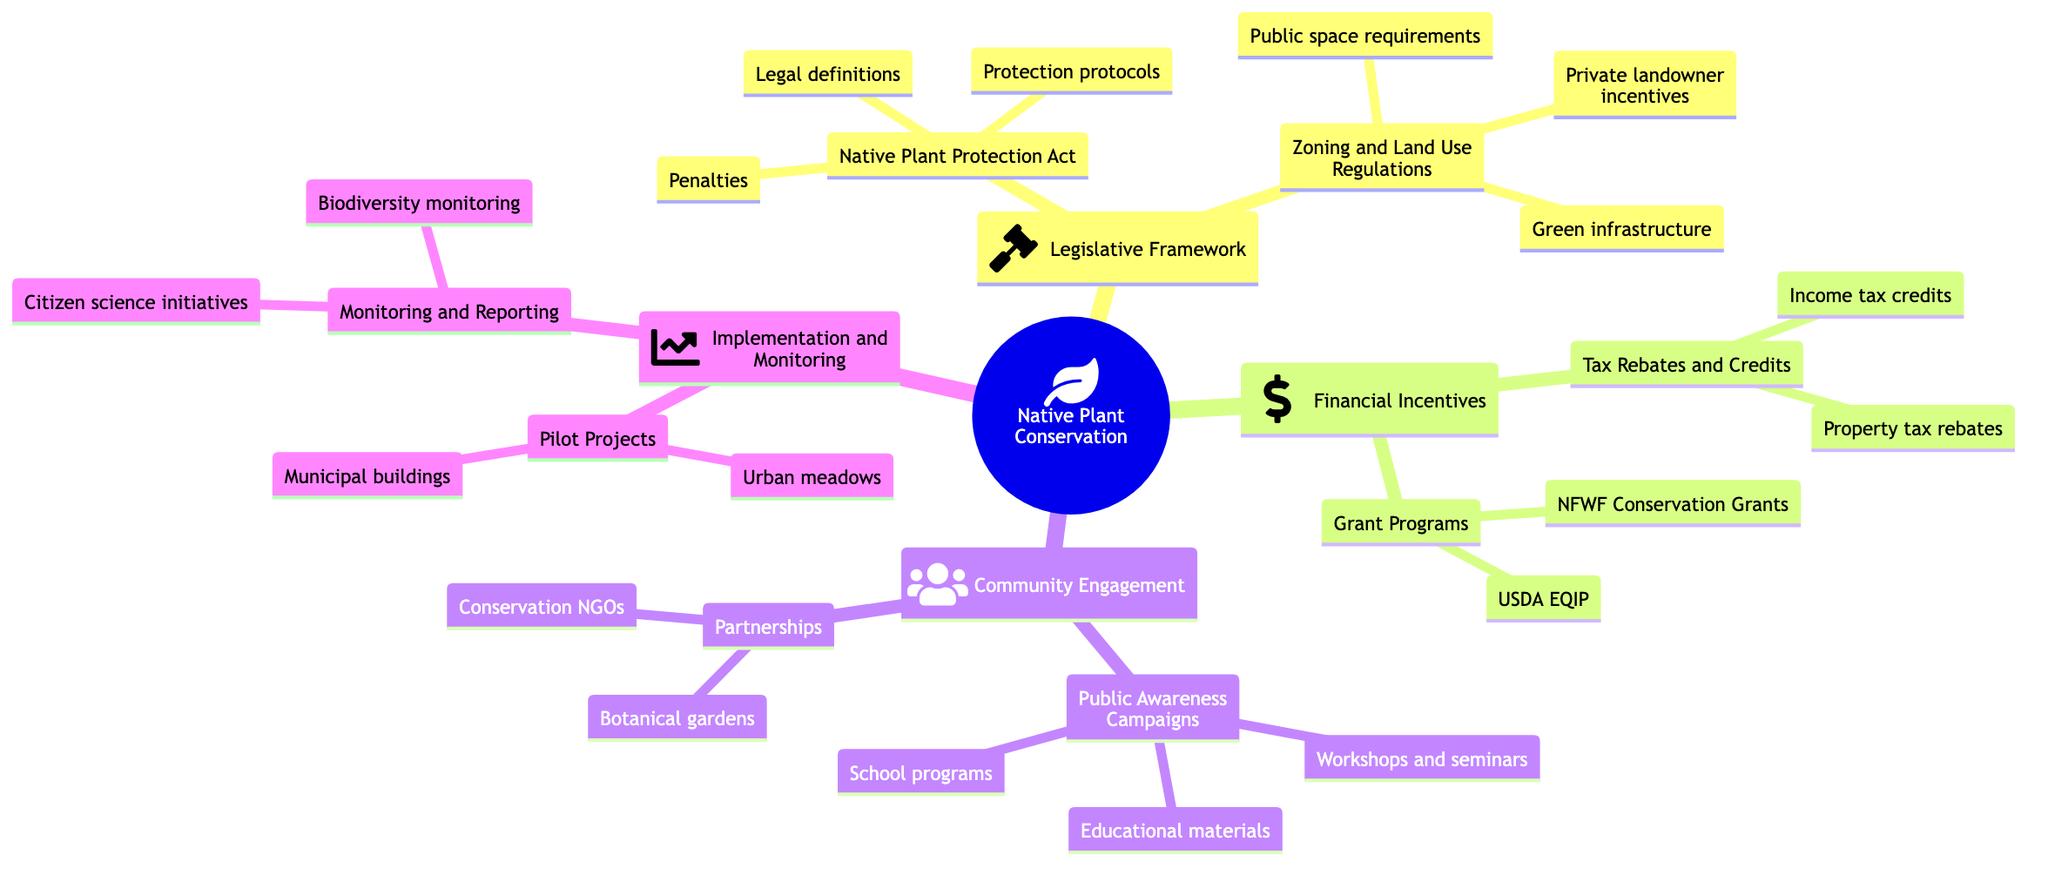What is one example of legislation protecting native plants? The diagram lists two examples under the "Native Plant Protection Act", which include the "California Native Plant Protection Act" and the "New York State Invasive Species Act".
Answer: California Native Plant Protection Act How many components are listed under "Tax Rebates and Credits"? The "Tax Rebates and Credits" section has two components: "Property tax rebates" and "Income tax credits". Thus, the count is based on these components.
Answer: 2 What is the purpose of "Public Awareness Campaigns"? The diagram states that the component aims to educate and involve the community, indicating its role in promoting understanding and engagement regarding native plant conservation.
Answer: Educate and involve Which section contains "Urban meadows in public parks"? The mention of "Urban meadows in public parks" identifies it as an example under "Pilot Projects", which is located within the "Implementation and Monitoring" section.
Answer: Pilot Projects What are two financial benefits mentioned for using native plants? The diagram highlights "Property tax rebates" and "Income tax credits" as benefits under "Tax Rebates and Credits". Therefore, they specifically apply to the financial incentives for native plant landscaping.
Answer: Property tax rebates, Income tax credits How many main categories are there in this mind map? The main branches include "Legislative Framework," "Financial Incentives," "Community Engagement," and "Implementation and Monitoring," totaling four primary categories depicted in the mind map.
Answer: 4 What is one example of a partnership mentioned in the diagram? Under "Partnerships with Local Organizations", the diagram lists "Collaborations with local botanical gardens" as an example, showcasing collaboration with an organization focused on plant conservation.
Answer: Collaborations with local botanical gardens What is the main goal of "Monitoring and Reporting"? The diagram notes that the purpose is ongoing assessment of policy effectiveness, which includes monitoring plant species diversity and compiling annual progress reports.
Answer: Ongoing assessment What does "Grant Programs" offer as a financial opportunity? The "Grant Programs" section of the diagram indicates that it provides funding opportunities specifically for projects related to native plant landscaping, supporting projects that align with conservation efforts.
Answer: Funding opportunities 